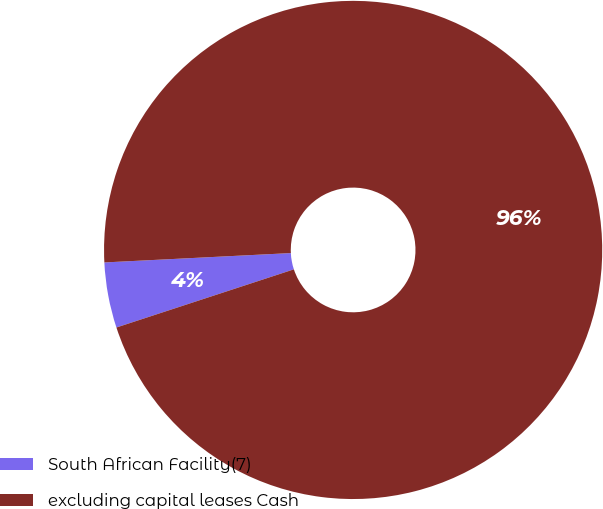Convert chart. <chart><loc_0><loc_0><loc_500><loc_500><pie_chart><fcel>South African Facility(7)<fcel>excluding capital leases Cash<nl><fcel>4.24%<fcel>95.76%<nl></chart> 